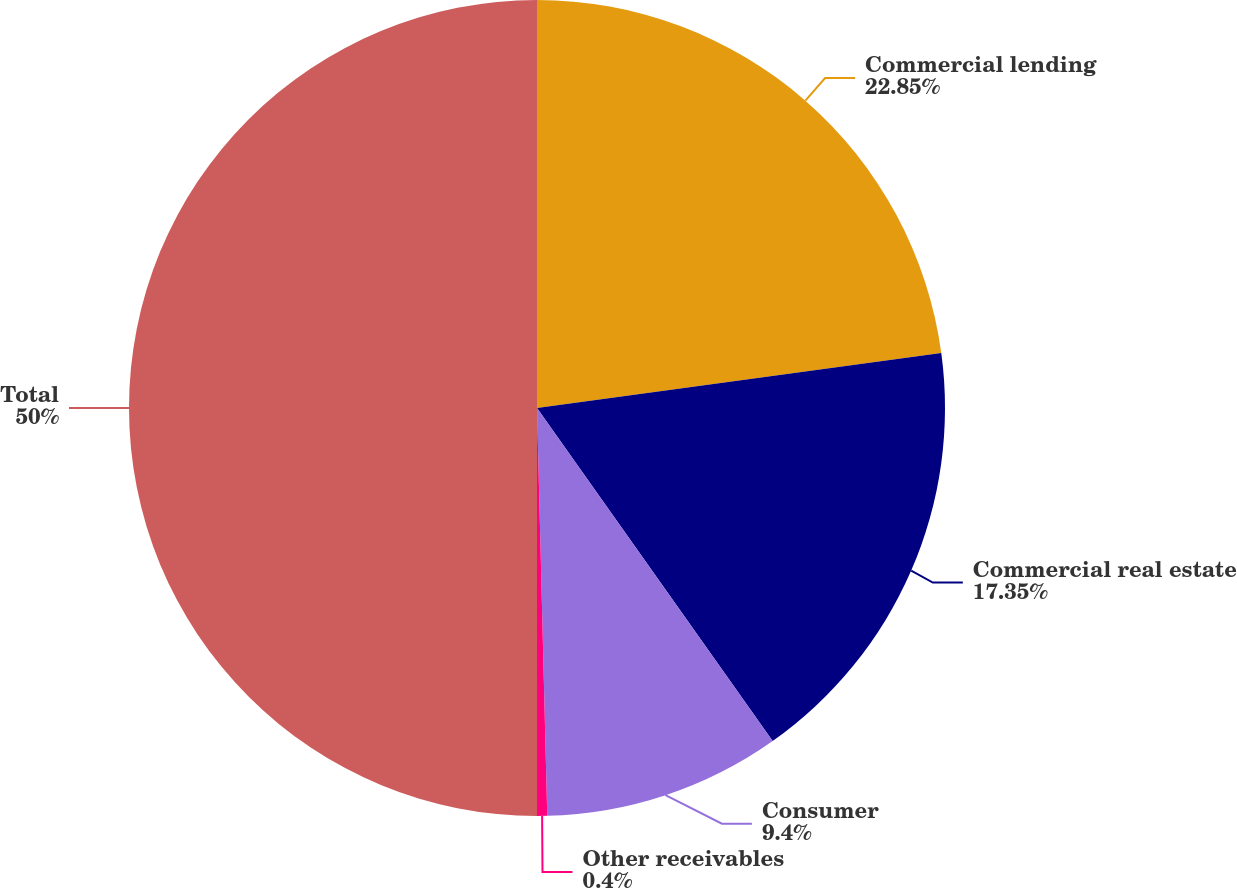Convert chart. <chart><loc_0><loc_0><loc_500><loc_500><pie_chart><fcel>Commercial lending<fcel>Commercial real estate<fcel>Consumer<fcel>Other receivables<fcel>Total<nl><fcel>22.85%<fcel>17.35%<fcel>9.4%<fcel>0.4%<fcel>50.0%<nl></chart> 